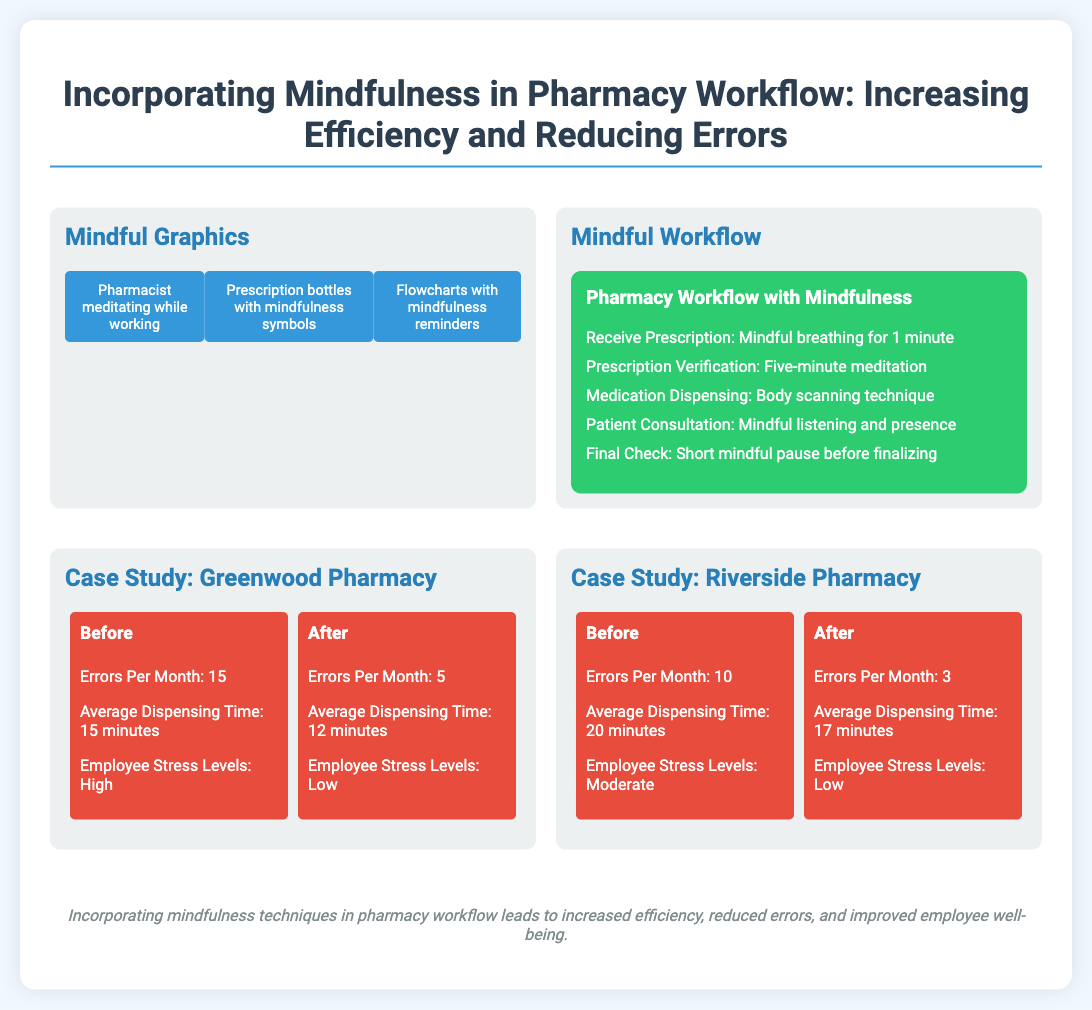What is the title of the poster? The title of the poster is displayed prominently at the top of the document.
Answer: Incorporating Mindfulness in Pharmacy Workflow: Increasing Efficiency and Reducing Errors How many errors were reported per month before mindfulness at Greenwood Pharmacy? The number of errors per month before mindfulness is stated in the case study section.
Answer: 15 What is the average dispensing time after mindfulness implementation at Riverside Pharmacy? The average dispensing time after mindfulness is mentioned in the case study section.
Answer: 17 minutes What mindfulness technique is suggested during prescription verification? The suggested technique is listed under the mindful workflow section.
Answer: Five-minute meditation How did employee stress levels change at Greenwood Pharmacy after mindfulness? The change in employee stress levels is compared in the case study section.
Answer: Low 